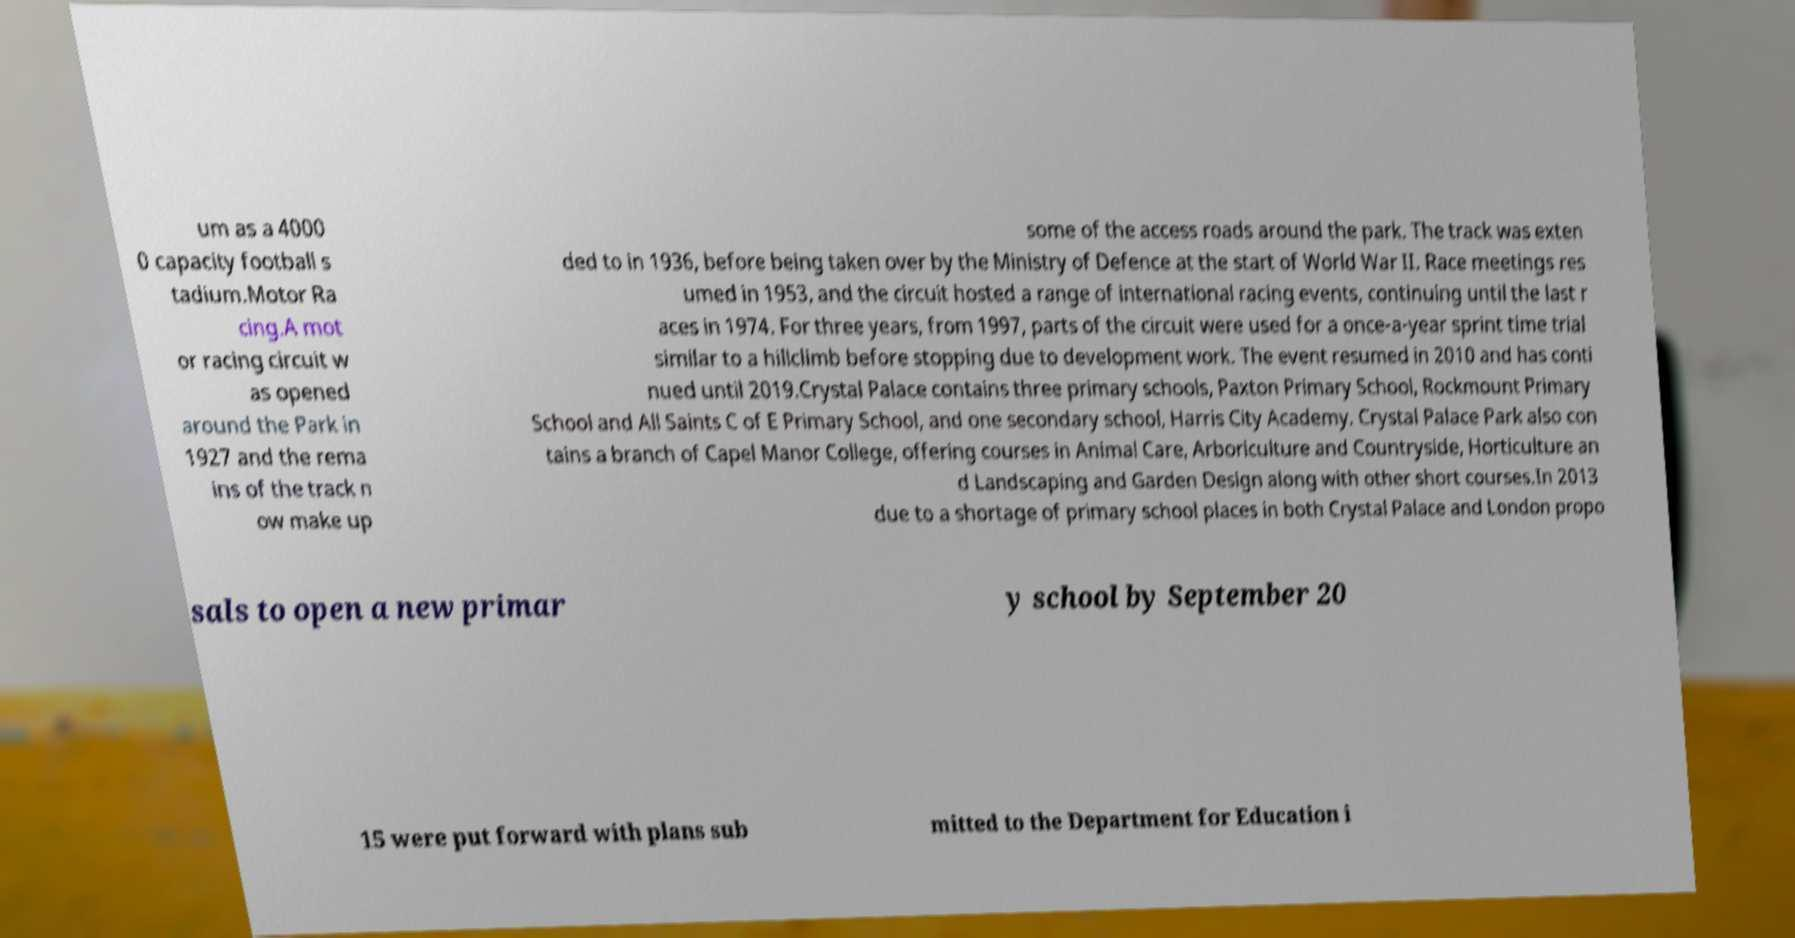I need the written content from this picture converted into text. Can you do that? um as a 4000 0 capacity football s tadium.Motor Ra cing.A mot or racing circuit w as opened around the Park in 1927 and the rema ins of the track n ow make up some of the access roads around the park. The track was exten ded to in 1936, before being taken over by the Ministry of Defence at the start of World War II. Race meetings res umed in 1953, and the circuit hosted a range of international racing events, continuing until the last r aces in 1974. For three years, from 1997, parts of the circuit were used for a once-a-year sprint time trial similar to a hillclimb before stopping due to development work. The event resumed in 2010 and has conti nued until 2019.Crystal Palace contains three primary schools, Paxton Primary School, Rockmount Primary School and All Saints C of E Primary School, and one secondary school, Harris City Academy. Crystal Palace Park also con tains a branch of Capel Manor College, offering courses in Animal Care, Arboriculture and Countryside, Horticulture an d Landscaping and Garden Design along with other short courses.In 2013 due to a shortage of primary school places in both Crystal Palace and London propo sals to open a new primar y school by September 20 15 were put forward with plans sub mitted to the Department for Education i 